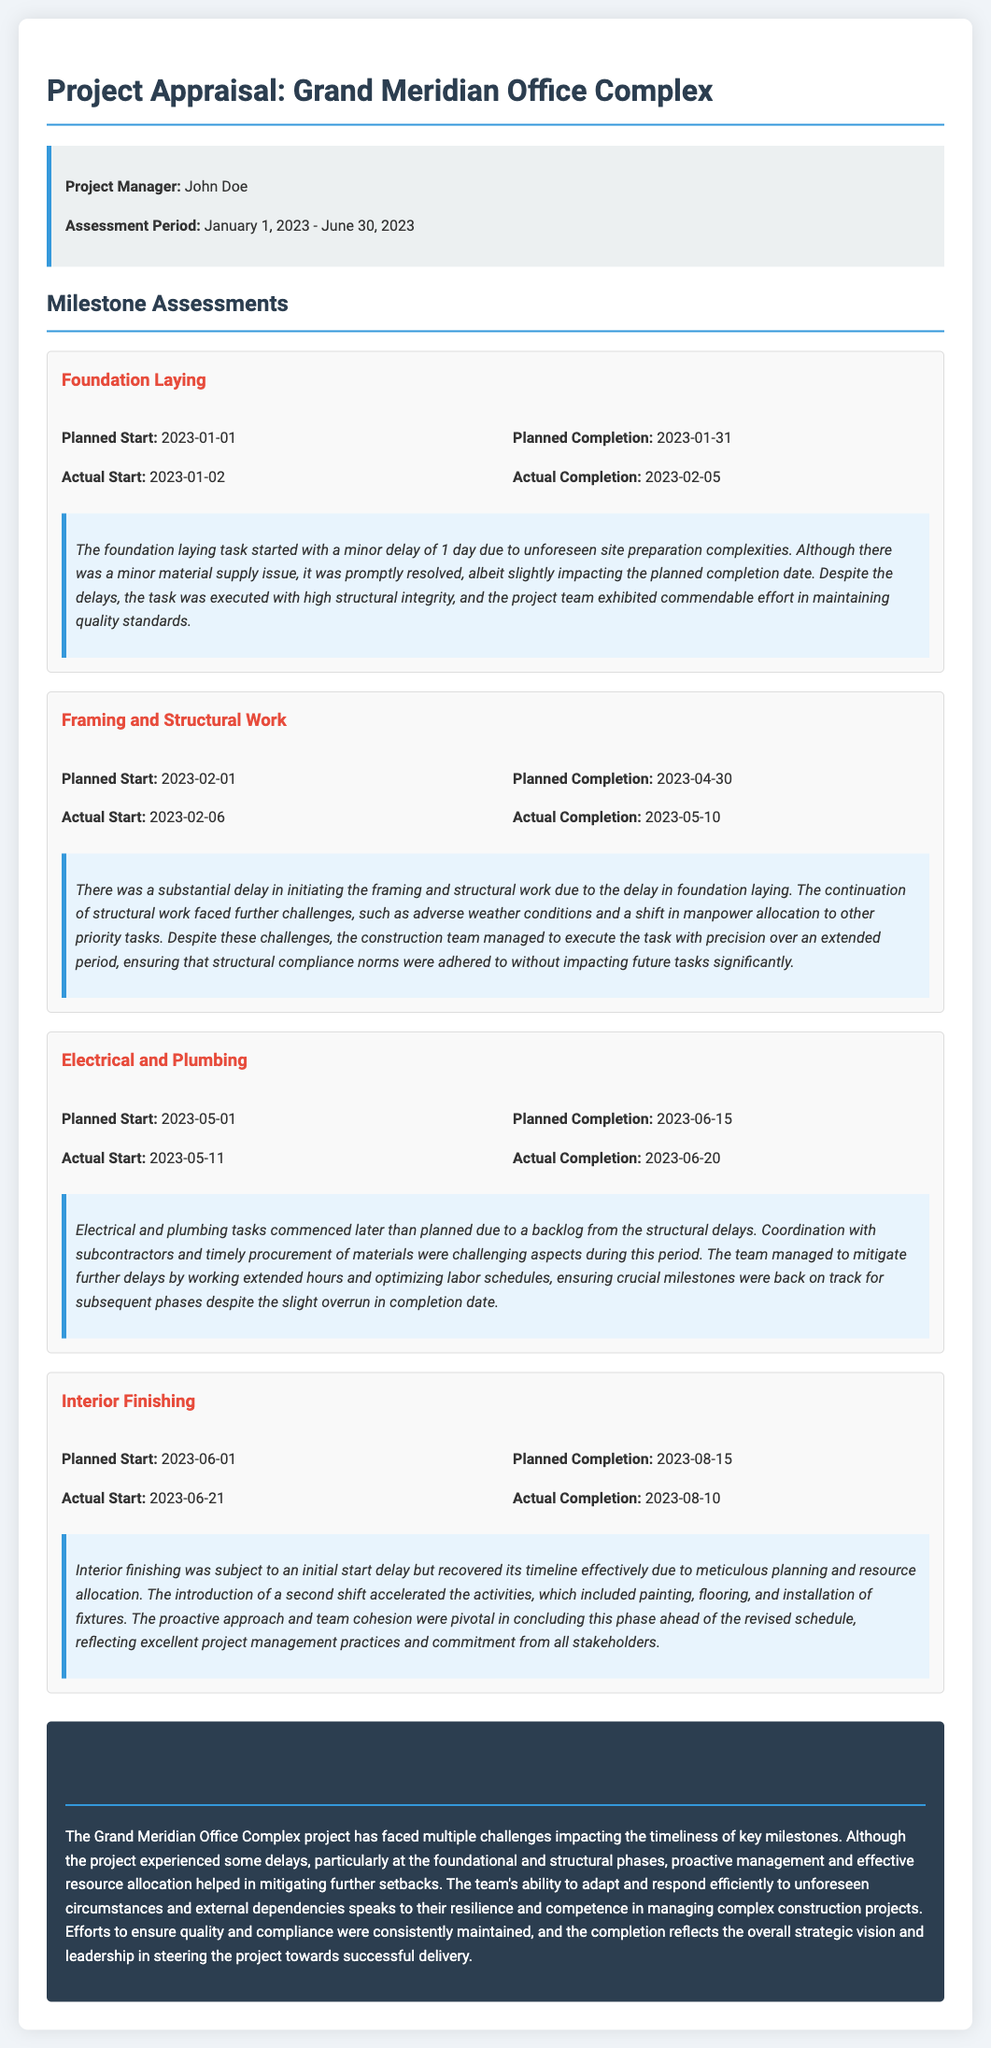What is the name of the project manager? The name of the project manager is mentioned in the project info section of the document.
Answer: John Doe What was the planned start date for Framing and Structural Work? The planned start date for Framing and Structural Work is specified under the milestone assessments for that task.
Answer: 2023-02-01 What was the actual completion date for Electrical and Plumbing? The actual completion date for Electrical and Plumbing is found in the corresponding milestone section of the document.
Answer: 2023-06-20 How many days was the Foundation Laying delayed? The delay in the Foundation Laying milestone is detailed in its commentary regarding timely execution.
Answer: 5 days What were the reasons for the delays in Framing and Structural Work? The commentary of the Framing and Structural Work milestone discusses reasons for delays based on external factors.
Answer: Adverse weather conditions and manpower allocation Was the Interior Finishing completed ahead of schedule? The commentary for the Interior Finishing milestone indicates if the task was completed ahead of its planned timeline.
Answer: Yes What is the overall assessment of the project's performance? The overall performance commentary gives a summary evaluation of the project's challenges and outcomes.
Answer: Resilience and competence When did the Interior Finishing task start? The start date for the Interior Finishing task is located in its milestone details.
Answer: 2023-06-21 